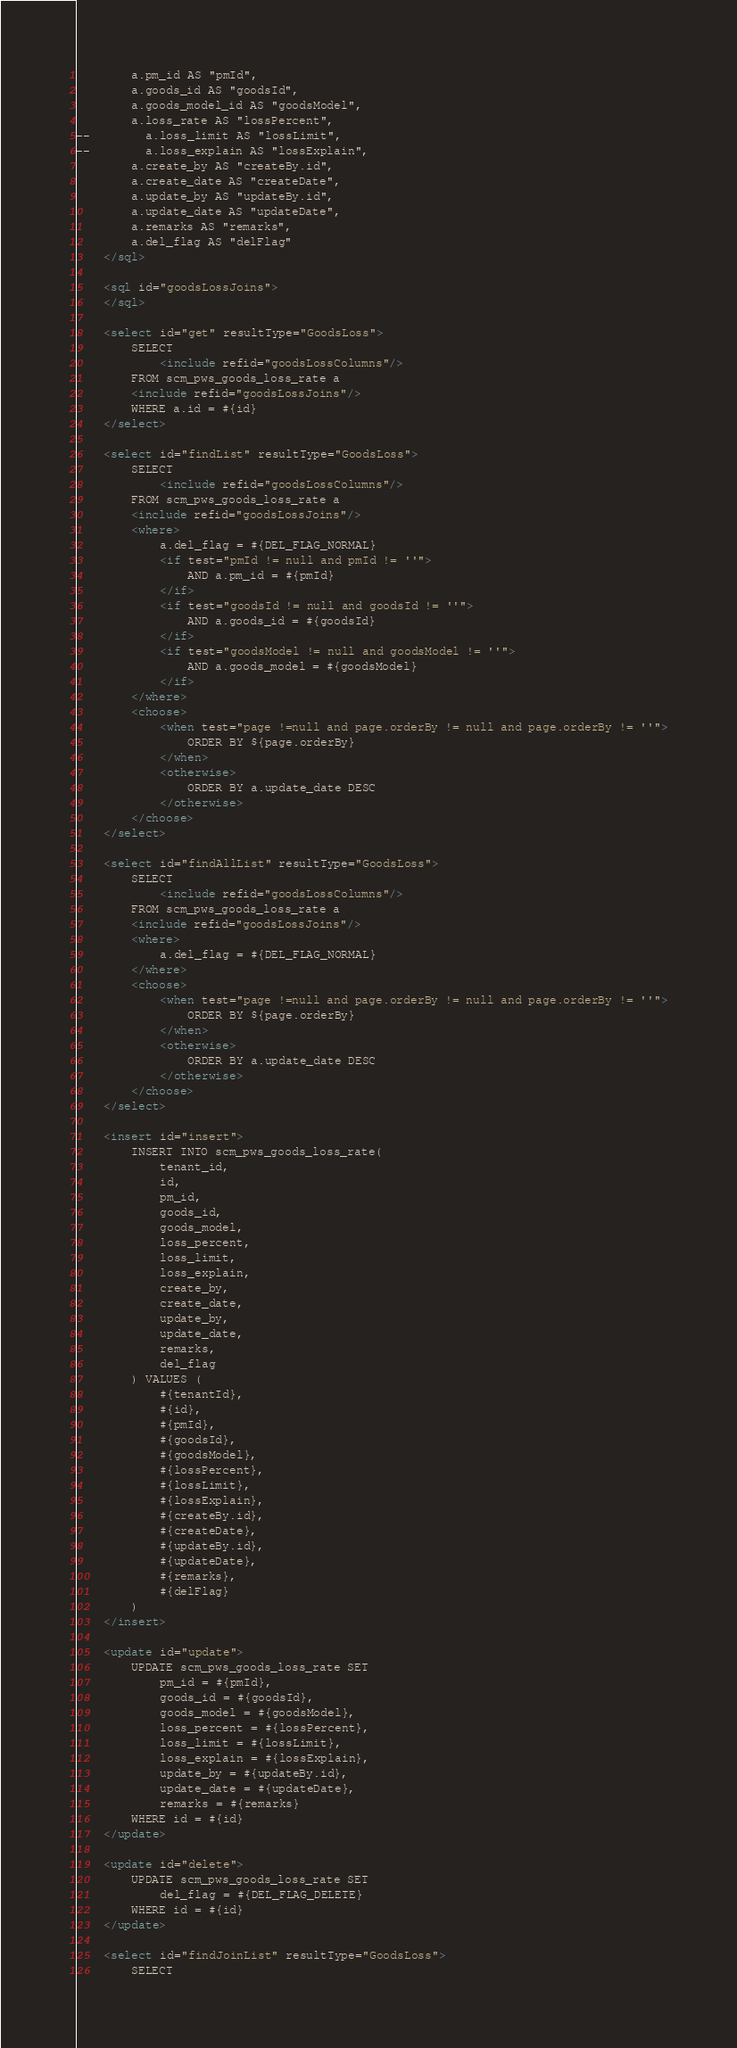Convert code to text. <code><loc_0><loc_0><loc_500><loc_500><_XML_>		a.pm_id AS "pmId",
		a.goods_id AS "goodsId",
		a.goods_model_id AS "goodsModel",
		a.loss_rate AS "lossPercent",
-- 		a.loss_limit AS "lossLimit",
-- 		a.loss_explain AS "lossExplain",
		a.create_by AS "createBy.id",
		a.create_date AS "createDate",
		a.update_by AS "updateBy.id",
		a.update_date AS "updateDate",
		a.remarks AS "remarks",
		a.del_flag AS "delFlag"
	</sql>
	
	<sql id="goodsLossJoins">
	</sql>
    
	<select id="get" resultType="GoodsLoss">
		SELECT 
			<include refid="goodsLossColumns"/>
		FROM scm_pws_goods_loss_rate a
		<include refid="goodsLossJoins"/>
		WHERE a.id = #{id}
	</select>
	
	<select id="findList" resultType="GoodsLoss">
		SELECT 
			<include refid="goodsLossColumns"/>
		FROM scm_pws_goods_loss_rate a
		<include refid="goodsLossJoins"/>
		<where>
			a.del_flag = #{DEL_FLAG_NORMAL}
			<if test="pmId != null and pmId != ''">
				AND a.pm_id = #{pmId}
			</if>
			<if test="goodsId != null and goodsId != ''">
				AND a.goods_id = #{goodsId}
			</if>
			<if test="goodsModel != null and goodsModel != ''">
				AND a.goods_model = #{goodsModel}
			</if>
		</where>
		<choose>
			<when test="page !=null and page.orderBy != null and page.orderBy != ''">
				ORDER BY ${page.orderBy}
			</when>
			<otherwise>
				ORDER BY a.update_date DESC
			</otherwise>
		</choose>
	</select>
	
	<select id="findAllList" resultType="GoodsLoss">
		SELECT 
			<include refid="goodsLossColumns"/>
		FROM scm_pws_goods_loss_rate a
		<include refid="goodsLossJoins"/>
		<where>
			a.del_flag = #{DEL_FLAG_NORMAL}
		</where>		
		<choose>
			<when test="page !=null and page.orderBy != null and page.orderBy != ''">
				ORDER BY ${page.orderBy}
			</when>
			<otherwise>
				ORDER BY a.update_date DESC
			</otherwise>
		</choose>
	</select>
	
	<insert id="insert">
		INSERT INTO scm_pws_goods_loss_rate(
			tenant_id,
			id,
			pm_id,
			goods_id,
			goods_model,
			loss_percent,
			loss_limit,
			loss_explain,
			create_by,
			create_date,
			update_by,
			update_date,
			remarks,
			del_flag
		) VALUES (
			#{tenantId},
			#{id},
			#{pmId},
			#{goodsId},
			#{goodsModel},
			#{lossPercent},
			#{lossLimit},
			#{lossExplain},
			#{createBy.id},
			#{createDate},
			#{updateBy.id},
			#{updateDate},
			#{remarks},
			#{delFlag}
		)
	</insert>
	
	<update id="update">
		UPDATE scm_pws_goods_loss_rate SET
			pm_id = #{pmId},
			goods_id = #{goodsId},
			goods_model = #{goodsModel},
			loss_percent = #{lossPercent},
			loss_limit = #{lossLimit},
			loss_explain = #{lossExplain},
			update_by = #{updateBy.id},
			update_date = #{updateDate},
			remarks = #{remarks}
		WHERE id = #{id}
	</update>
	
	<update id="delete">
		UPDATE scm_pws_goods_loss_rate SET
			del_flag = #{DEL_FLAG_DELETE}
		WHERE id = #{id}
	</update>

    <select id="findJoinList" resultType="GoodsLoss">
        SELECT</code> 